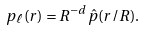<formula> <loc_0><loc_0><loc_500><loc_500>p _ { \ell } ( r ) = R ^ { - d } \hat { p } ( r / R ) .</formula> 